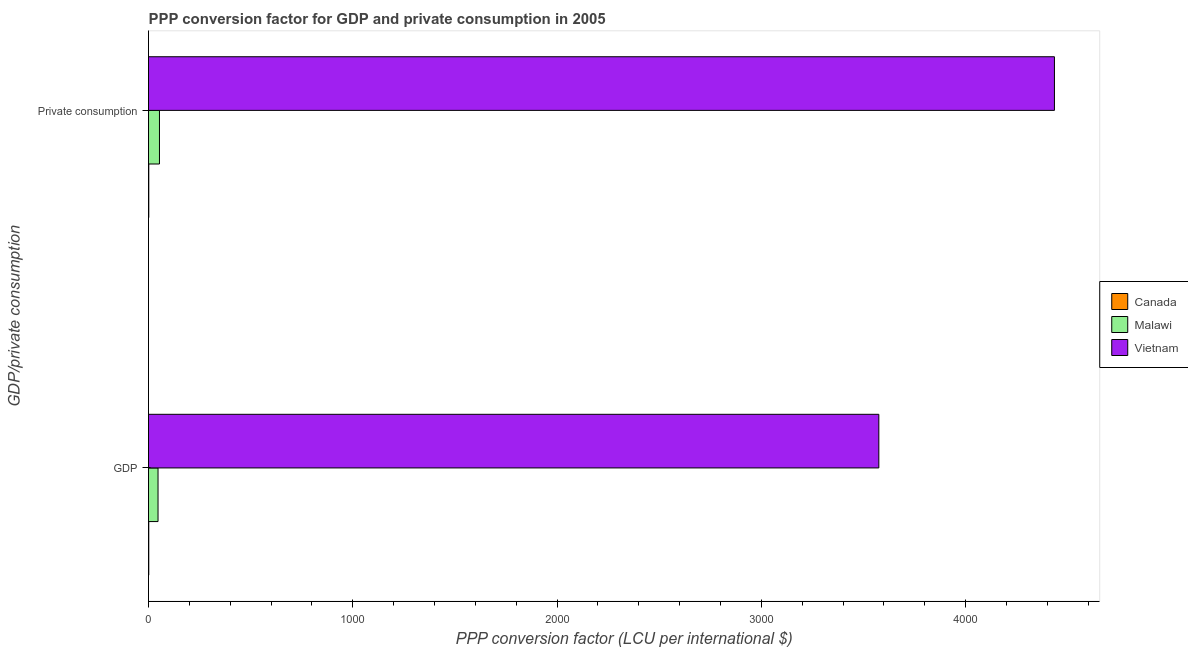How many different coloured bars are there?
Your answer should be compact. 3. What is the label of the 1st group of bars from the top?
Ensure brevity in your answer.   Private consumption. What is the ppp conversion factor for private consumption in Vietnam?
Ensure brevity in your answer.  4434.71. Across all countries, what is the maximum ppp conversion factor for gdp?
Offer a very short reply. 3575.1. Across all countries, what is the minimum ppp conversion factor for gdp?
Ensure brevity in your answer.  1.21. In which country was the ppp conversion factor for gdp maximum?
Offer a terse response. Vietnam. What is the total ppp conversion factor for gdp in the graph?
Provide a short and direct response. 3622.86. What is the difference between the ppp conversion factor for private consumption in Canada and that in Vietnam?
Make the answer very short. -4433.45. What is the difference between the ppp conversion factor for gdp in Canada and the ppp conversion factor for private consumption in Malawi?
Provide a succinct answer. -52.39. What is the average ppp conversion factor for gdp per country?
Make the answer very short. 1207.62. What is the difference between the ppp conversion factor for private consumption and ppp conversion factor for gdp in Malawi?
Keep it short and to the point. 7.05. What is the ratio of the ppp conversion factor for private consumption in Canada to that in Malawi?
Your answer should be very brief. 0.02. Is the ppp conversion factor for private consumption in Vietnam less than that in Malawi?
Provide a succinct answer. No. In how many countries, is the ppp conversion factor for gdp greater than the average ppp conversion factor for gdp taken over all countries?
Make the answer very short. 1. What does the 3rd bar from the bottom in GDP represents?
Your answer should be compact. Vietnam. What is the difference between two consecutive major ticks on the X-axis?
Offer a terse response. 1000. Where does the legend appear in the graph?
Your response must be concise. Center right. How many legend labels are there?
Offer a very short reply. 3. What is the title of the graph?
Make the answer very short. PPP conversion factor for GDP and private consumption in 2005. What is the label or title of the X-axis?
Keep it short and to the point. PPP conversion factor (LCU per international $). What is the label or title of the Y-axis?
Your answer should be very brief. GDP/private consumption. What is the PPP conversion factor (LCU per international $) of Canada in GDP?
Your answer should be very brief. 1.21. What is the PPP conversion factor (LCU per international $) in Malawi in GDP?
Offer a terse response. 46.55. What is the PPP conversion factor (LCU per international $) of Vietnam in GDP?
Provide a succinct answer. 3575.1. What is the PPP conversion factor (LCU per international $) in Canada in  Private consumption?
Give a very brief answer. 1.26. What is the PPP conversion factor (LCU per international $) in Malawi in  Private consumption?
Keep it short and to the point. 53.6. What is the PPP conversion factor (LCU per international $) in Vietnam in  Private consumption?
Provide a short and direct response. 4434.71. Across all GDP/private consumption, what is the maximum PPP conversion factor (LCU per international $) in Canada?
Provide a short and direct response. 1.26. Across all GDP/private consumption, what is the maximum PPP conversion factor (LCU per international $) in Malawi?
Ensure brevity in your answer.  53.6. Across all GDP/private consumption, what is the maximum PPP conversion factor (LCU per international $) of Vietnam?
Your response must be concise. 4434.71. Across all GDP/private consumption, what is the minimum PPP conversion factor (LCU per international $) in Canada?
Your answer should be very brief. 1.21. Across all GDP/private consumption, what is the minimum PPP conversion factor (LCU per international $) of Malawi?
Ensure brevity in your answer.  46.55. Across all GDP/private consumption, what is the minimum PPP conversion factor (LCU per international $) of Vietnam?
Make the answer very short. 3575.1. What is the total PPP conversion factor (LCU per international $) in Canada in the graph?
Keep it short and to the point. 2.47. What is the total PPP conversion factor (LCU per international $) in Malawi in the graph?
Your answer should be compact. 100.15. What is the total PPP conversion factor (LCU per international $) of Vietnam in the graph?
Make the answer very short. 8009.81. What is the difference between the PPP conversion factor (LCU per international $) in Canada in GDP and that in  Private consumption?
Provide a short and direct response. -0.05. What is the difference between the PPP conversion factor (LCU per international $) of Malawi in GDP and that in  Private consumption?
Ensure brevity in your answer.  -7.05. What is the difference between the PPP conversion factor (LCU per international $) in Vietnam in GDP and that in  Private consumption?
Your response must be concise. -859.61. What is the difference between the PPP conversion factor (LCU per international $) of Canada in GDP and the PPP conversion factor (LCU per international $) of Malawi in  Private consumption?
Provide a succinct answer. -52.39. What is the difference between the PPP conversion factor (LCU per international $) in Canada in GDP and the PPP conversion factor (LCU per international $) in Vietnam in  Private consumption?
Provide a succinct answer. -4433.5. What is the difference between the PPP conversion factor (LCU per international $) of Malawi in GDP and the PPP conversion factor (LCU per international $) of Vietnam in  Private consumption?
Offer a very short reply. -4388.16. What is the average PPP conversion factor (LCU per international $) of Canada per GDP/private consumption?
Your answer should be compact. 1.24. What is the average PPP conversion factor (LCU per international $) in Malawi per GDP/private consumption?
Make the answer very short. 50.08. What is the average PPP conversion factor (LCU per international $) of Vietnam per GDP/private consumption?
Your response must be concise. 4004.91. What is the difference between the PPP conversion factor (LCU per international $) in Canada and PPP conversion factor (LCU per international $) in Malawi in GDP?
Your response must be concise. -45.34. What is the difference between the PPP conversion factor (LCU per international $) in Canada and PPP conversion factor (LCU per international $) in Vietnam in GDP?
Make the answer very short. -3573.89. What is the difference between the PPP conversion factor (LCU per international $) in Malawi and PPP conversion factor (LCU per international $) in Vietnam in GDP?
Provide a succinct answer. -3528.55. What is the difference between the PPP conversion factor (LCU per international $) of Canada and PPP conversion factor (LCU per international $) of Malawi in  Private consumption?
Give a very brief answer. -52.34. What is the difference between the PPP conversion factor (LCU per international $) of Canada and PPP conversion factor (LCU per international $) of Vietnam in  Private consumption?
Offer a very short reply. -4433.45. What is the difference between the PPP conversion factor (LCU per international $) in Malawi and PPP conversion factor (LCU per international $) in Vietnam in  Private consumption?
Give a very brief answer. -4381.11. What is the ratio of the PPP conversion factor (LCU per international $) of Canada in GDP to that in  Private consumption?
Provide a succinct answer. 0.96. What is the ratio of the PPP conversion factor (LCU per international $) in Malawi in GDP to that in  Private consumption?
Give a very brief answer. 0.87. What is the ratio of the PPP conversion factor (LCU per international $) of Vietnam in GDP to that in  Private consumption?
Provide a succinct answer. 0.81. What is the difference between the highest and the second highest PPP conversion factor (LCU per international $) of Canada?
Offer a terse response. 0.05. What is the difference between the highest and the second highest PPP conversion factor (LCU per international $) in Malawi?
Your response must be concise. 7.05. What is the difference between the highest and the second highest PPP conversion factor (LCU per international $) of Vietnam?
Ensure brevity in your answer.  859.61. What is the difference between the highest and the lowest PPP conversion factor (LCU per international $) in Canada?
Provide a succinct answer. 0.05. What is the difference between the highest and the lowest PPP conversion factor (LCU per international $) of Malawi?
Offer a terse response. 7.05. What is the difference between the highest and the lowest PPP conversion factor (LCU per international $) in Vietnam?
Your response must be concise. 859.61. 